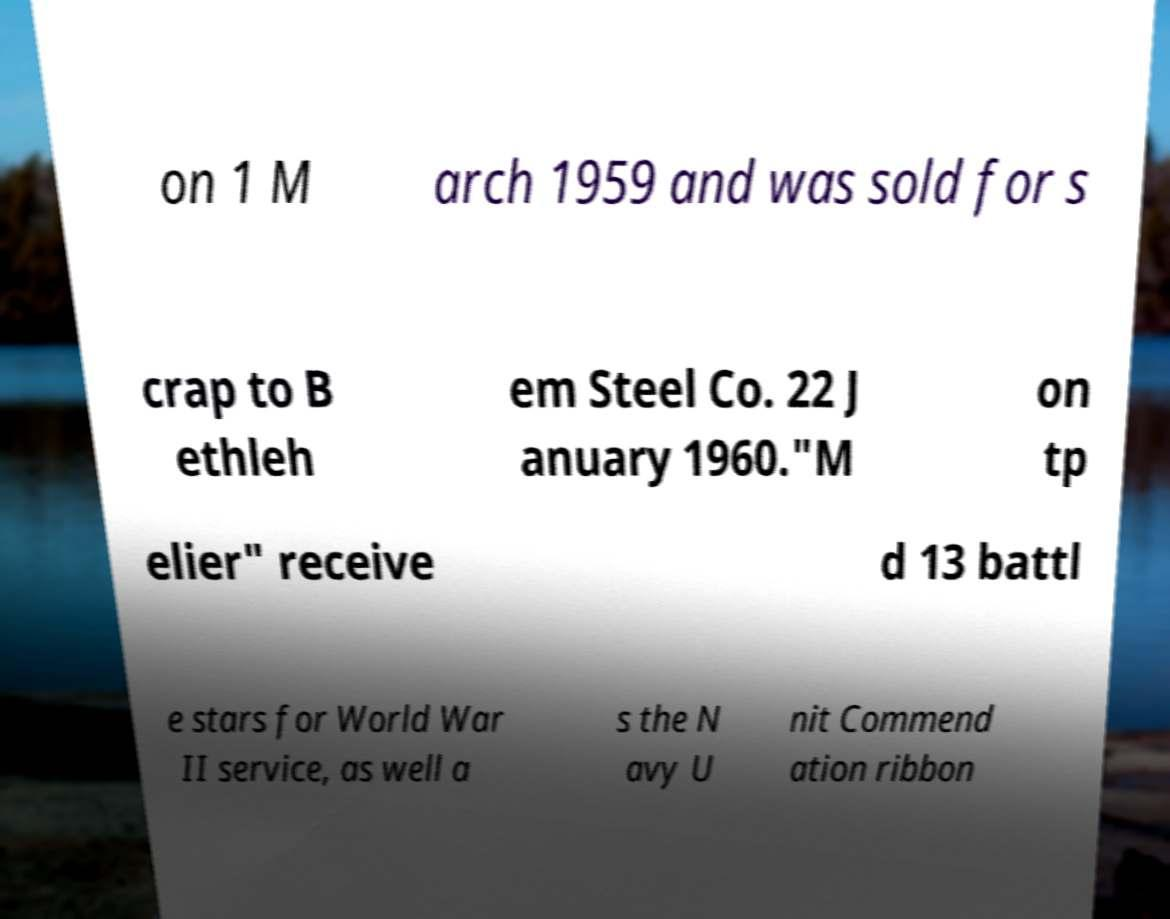Can you read and provide the text displayed in the image?This photo seems to have some interesting text. Can you extract and type it out for me? on 1 M arch 1959 and was sold for s crap to B ethleh em Steel Co. 22 J anuary 1960."M on tp elier" receive d 13 battl e stars for World War II service, as well a s the N avy U nit Commend ation ribbon 